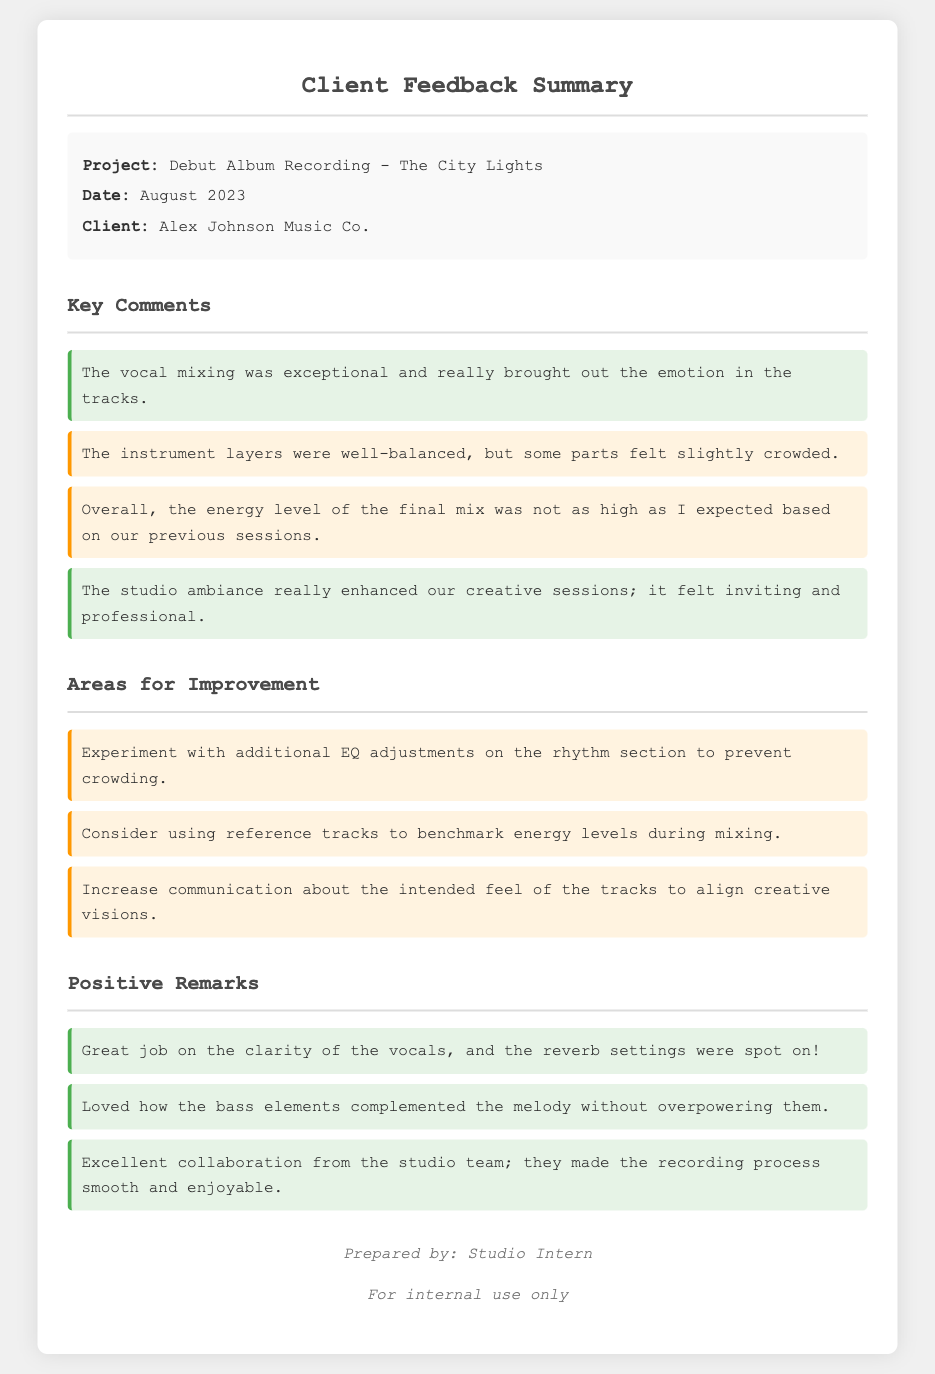What is the project name? The project name is listed at the beginning of the memo under project information.
Answer: Debut Album Recording - The City Lights What date was the feedback collected? The date of the project is mentioned in the project information section.
Answer: August 2023 Who is the client? The client's name is provided in the project information section.
Answer: Alex Johnson Music Co What positive remark was made about vocal mixing? The memo highlights a positive comment about vocal mixing among other comments.
Answer: Exceptional What area for improvement was suggested regarding energy levels? The feedback mentions an issue with the energy levels compared to previous sessions.
Answer: Higher What did the feedback say about the studio ambiance? Positive remarks are included regarding the studio ambiance enhancing creative sessions.
Answer: Inviting and professional Which section contains suggestions for improvement? The memo is divided into sections, and one specifically addresses areas that need improvement.
Answer: Areas for Improvement How many positive remarks are listed? The memo includes a specific list of positive remarks, and counting them will provide the answer.
Answer: Three What is noted about the bass elements? There is a positive comment regarding how the bass elements interacted with the melody.
Answer: Complemented the melody without overpowering 